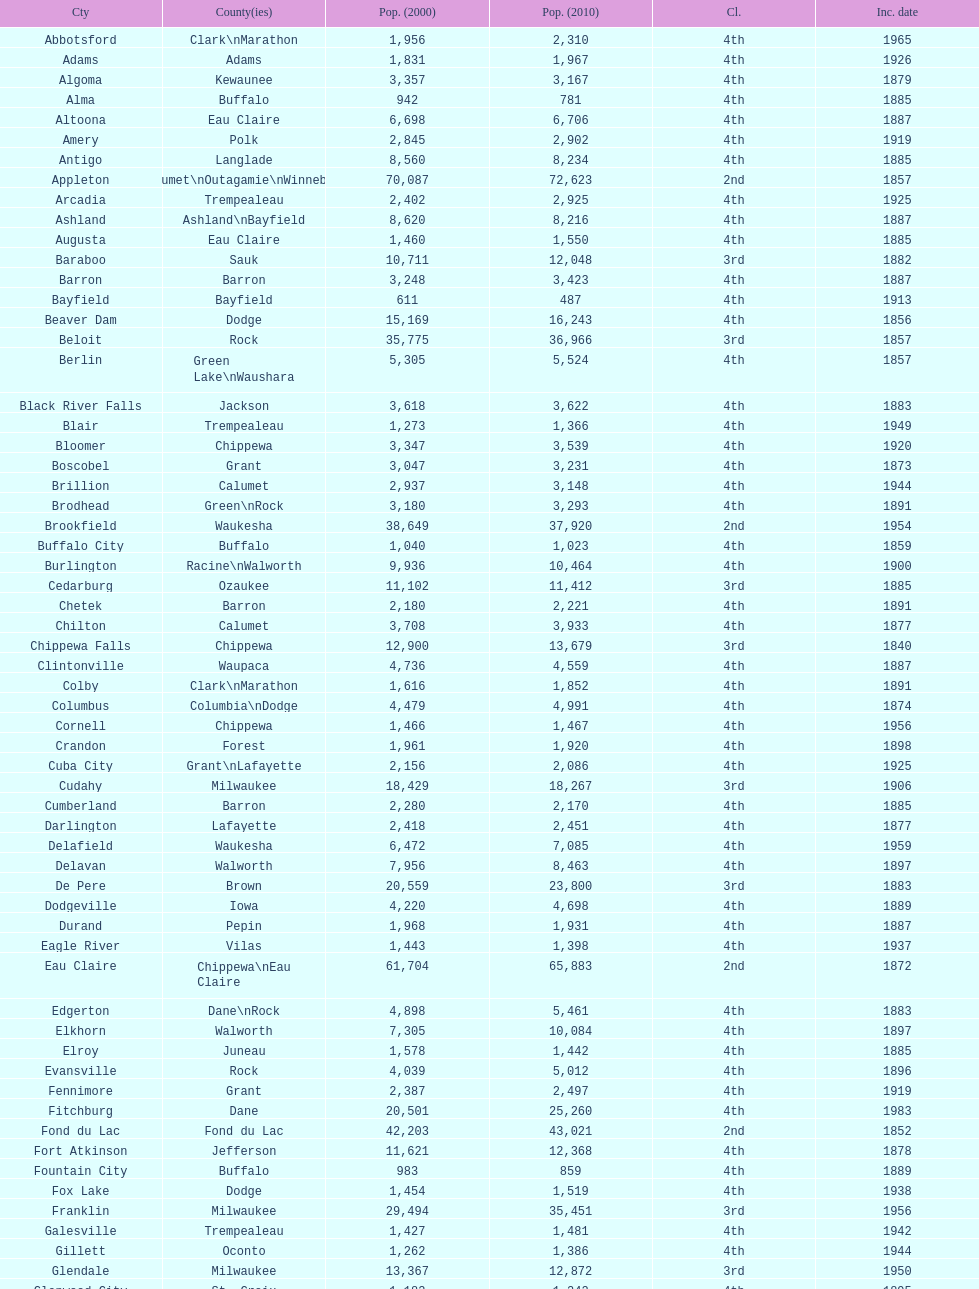County has altoona and augusta? Eau Claire. 